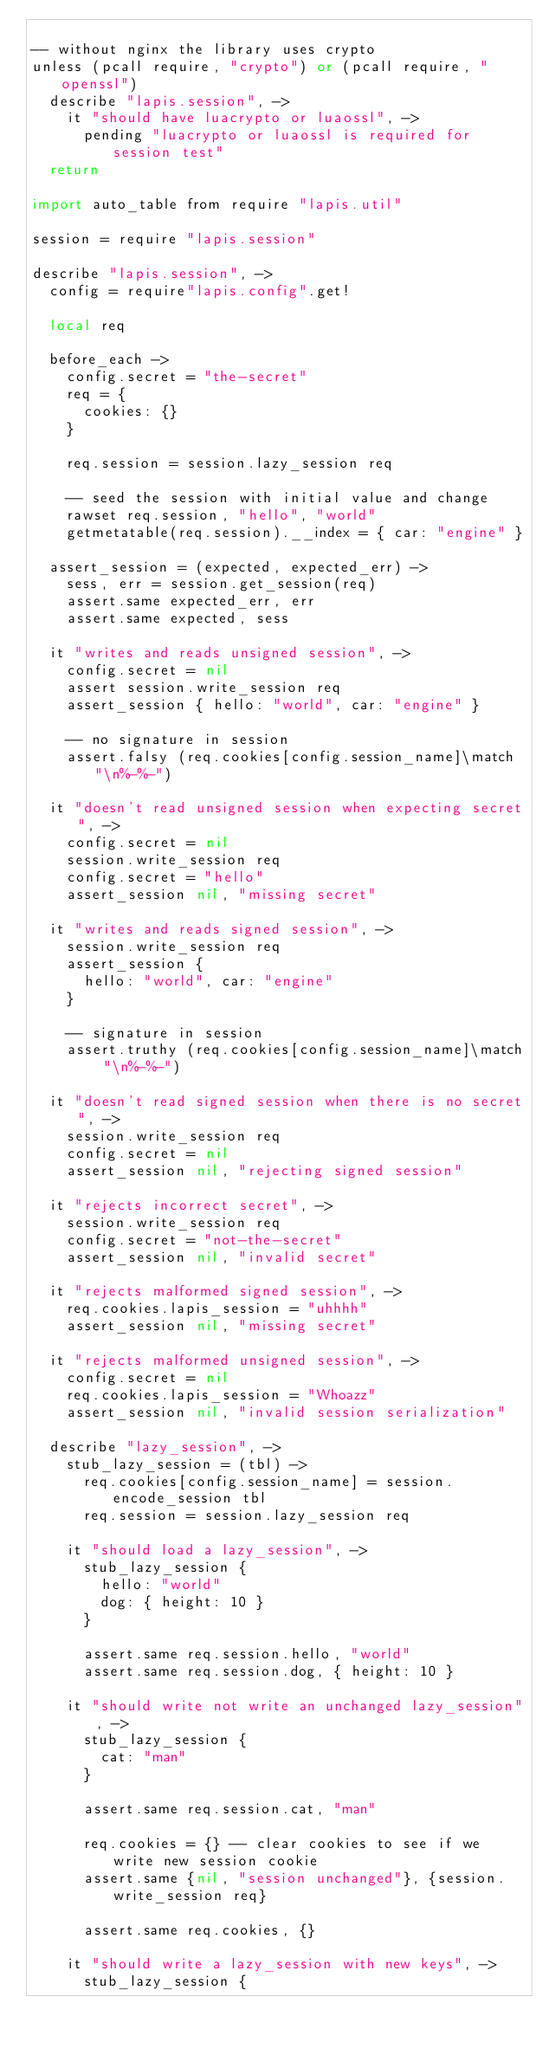<code> <loc_0><loc_0><loc_500><loc_500><_MoonScript_>
-- without nginx the library uses crypto
unless (pcall require, "crypto") or (pcall require, "openssl")
  describe "lapis.session", ->
    it "should have luacrypto or luaossl", ->
      pending "luacrypto or luaossl is required for session test"
  return

import auto_table from require "lapis.util"

session = require "lapis.session"

describe "lapis.session", ->
  config = require"lapis.config".get!

  local req

  before_each ->
    config.secret = "the-secret"
    req = {
      cookies: {}
    }

    req.session = session.lazy_session req

    -- seed the session with initial value and change
    rawset req.session, "hello", "world"
    getmetatable(req.session).__index = { car: "engine" }

  assert_session = (expected, expected_err) ->
    sess, err = session.get_session(req)
    assert.same expected_err, err
    assert.same expected, sess

  it "writes and reads unsigned session", ->
    config.secret = nil
    assert session.write_session req
    assert_session { hello: "world", car: "engine" }

    -- no signature in session
    assert.falsy (req.cookies[config.session_name]\match "\n%-%-")

  it "doesn't read unsigned session when expecting secret", ->
    config.secret = nil
    session.write_session req
    config.secret = "hello"
    assert_session nil, "missing secret"

  it "writes and reads signed session", ->
    session.write_session req
    assert_session {
      hello: "world", car: "engine"
    }

    -- signature in session
    assert.truthy (req.cookies[config.session_name]\match "\n%-%-")

  it "doesn't read signed session when there is no secret", ->
    session.write_session req
    config.secret = nil
    assert_session nil, "rejecting signed session"

  it "rejects incorrect secret", ->
    session.write_session req
    config.secret = "not-the-secret"
    assert_session nil, "invalid secret"

  it "rejects malformed signed session", ->
    req.cookies.lapis_session = "uhhhh"
    assert_session nil, "missing secret"

  it "rejects malformed unsigned session", ->
    config.secret = nil
    req.cookies.lapis_session = "Whoazz"
    assert_session nil, "invalid session serialization"

  describe "lazy_session", ->
    stub_lazy_session = (tbl) ->
      req.cookies[config.session_name] = session.encode_session tbl
      req.session = session.lazy_session req

    it "should load a lazy_session", ->
      stub_lazy_session {
        hello: "world"
        dog: { height: 10 }
      }

      assert.same req.session.hello, "world"
      assert.same req.session.dog, { height: 10 }

    it "should write not write an unchanged lazy_session", ->
      stub_lazy_session {
        cat: "man"
      }

      assert.same req.session.cat, "man"

      req.cookies = {} -- clear cookies to see if we write new session cookie
      assert.same {nil, "session unchanged"}, {session.write_session req}

      assert.same req.cookies, {}

    it "should write a lazy_session with new keys", ->
      stub_lazy_session {</code> 